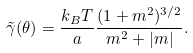<formula> <loc_0><loc_0><loc_500><loc_500>\tilde { \gamma } ( \theta ) = \frac { k _ { B } T } { a } \frac { ( 1 + m ^ { 2 } ) ^ { 3 / 2 } } { m ^ { 2 } + | m | } .</formula> 